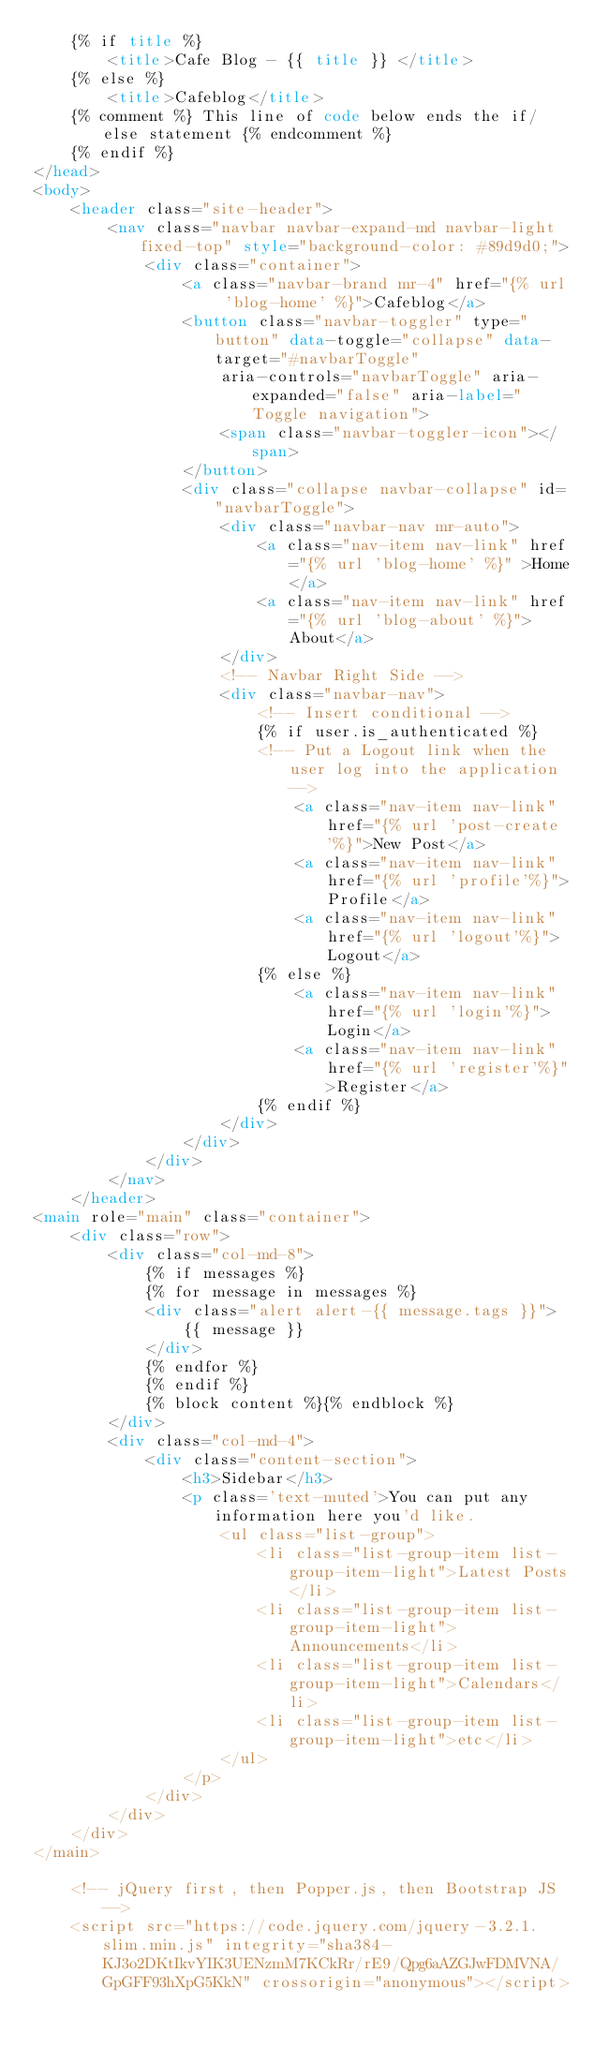Convert code to text. <code><loc_0><loc_0><loc_500><loc_500><_HTML_>    {% if title %}
        <title>Cafe Blog - {{ title }} </title>
    {% else %}
        <title>Cafeblog</title>
    {% comment %} This line of code below ends the if/else statement {% endcomment %}
    {% endif %}
</head>
<body>
    <header class="site-header">
        <nav class="navbar navbar-expand-md navbar-light fixed-top" style="background-color: #89d9d0;">
            <div class="container">
                <a class="navbar-brand mr-4" href="{% url 'blog-home' %}">Cafeblog</a>
                <button class="navbar-toggler" type="button" data-toggle="collapse" data-target="#navbarToggle"
                    aria-controls="navbarToggle" aria-expanded="false" aria-label="Toggle navigation">
                    <span class="navbar-toggler-icon"></span>
                </button>
                <div class="collapse navbar-collapse" id="navbarToggle">
                    <div class="navbar-nav mr-auto">
                        <a class="nav-item nav-link" href="{% url 'blog-home' %}" >Home</a>
                        <a class="nav-item nav-link" href="{% url 'blog-about' %}">About</a>
                    </div>
                    <!-- Navbar Right Side -->
                    <div class="navbar-nav">
                        <!-- Insert conditional -->
                        {% if user.is_authenticated %}
                        <!-- Put a Logout link when the user log into the application -->
                            <a class="nav-item nav-link" href="{% url 'post-create'%}">New Post</a>
                            <a class="nav-item nav-link" href="{% url 'profile'%}">Profile</a>
                            <a class="nav-item nav-link" href="{% url 'logout'%}">Logout</a>
                        {% else %}
                            <a class="nav-item nav-link" href="{% url 'login'%}">Login</a>
                            <a class="nav-item nav-link" href="{% url 'register'%}">Register</a>
                        {% endif %}
                    </div>
                </div>
            </div>
        </nav>
    </header>
<main role="main" class="container">
    <div class="row">
        <div class="col-md-8">
            {% if messages %}
            {% for message in messages %}
            <div class="alert alert-{{ message.tags }}">
                {{ message }}
            </div>
            {% endfor %}
            {% endif %}
            {% block content %}{% endblock %}
        </div>
        <div class="col-md-4">
            <div class="content-section">
                <h3>Sidebar</h3>
                <p class='text-muted'>You can put any information here you'd like.
                    <ul class="list-group">
                        <li class="list-group-item list-group-item-light">Latest Posts</li>
                        <li class="list-group-item list-group-item-light">Announcements</li>
                        <li class="list-group-item list-group-item-light">Calendars</li>
                        <li class="list-group-item list-group-item-light">etc</li>
                    </ul>
                </p>
            </div>
        </div>
    </div>
</main>

    <!-- jQuery first, then Popper.js, then Bootstrap JS -->
    <script src="https://code.jquery.com/jquery-3.2.1.slim.min.js" integrity="sha384-KJ3o2DKtIkvYIK3UENzmM7KCkRr/rE9/Qpg6aAZGJwFDMVNA/GpGFF93hXpG5KkN" crossorigin="anonymous"></script></code> 